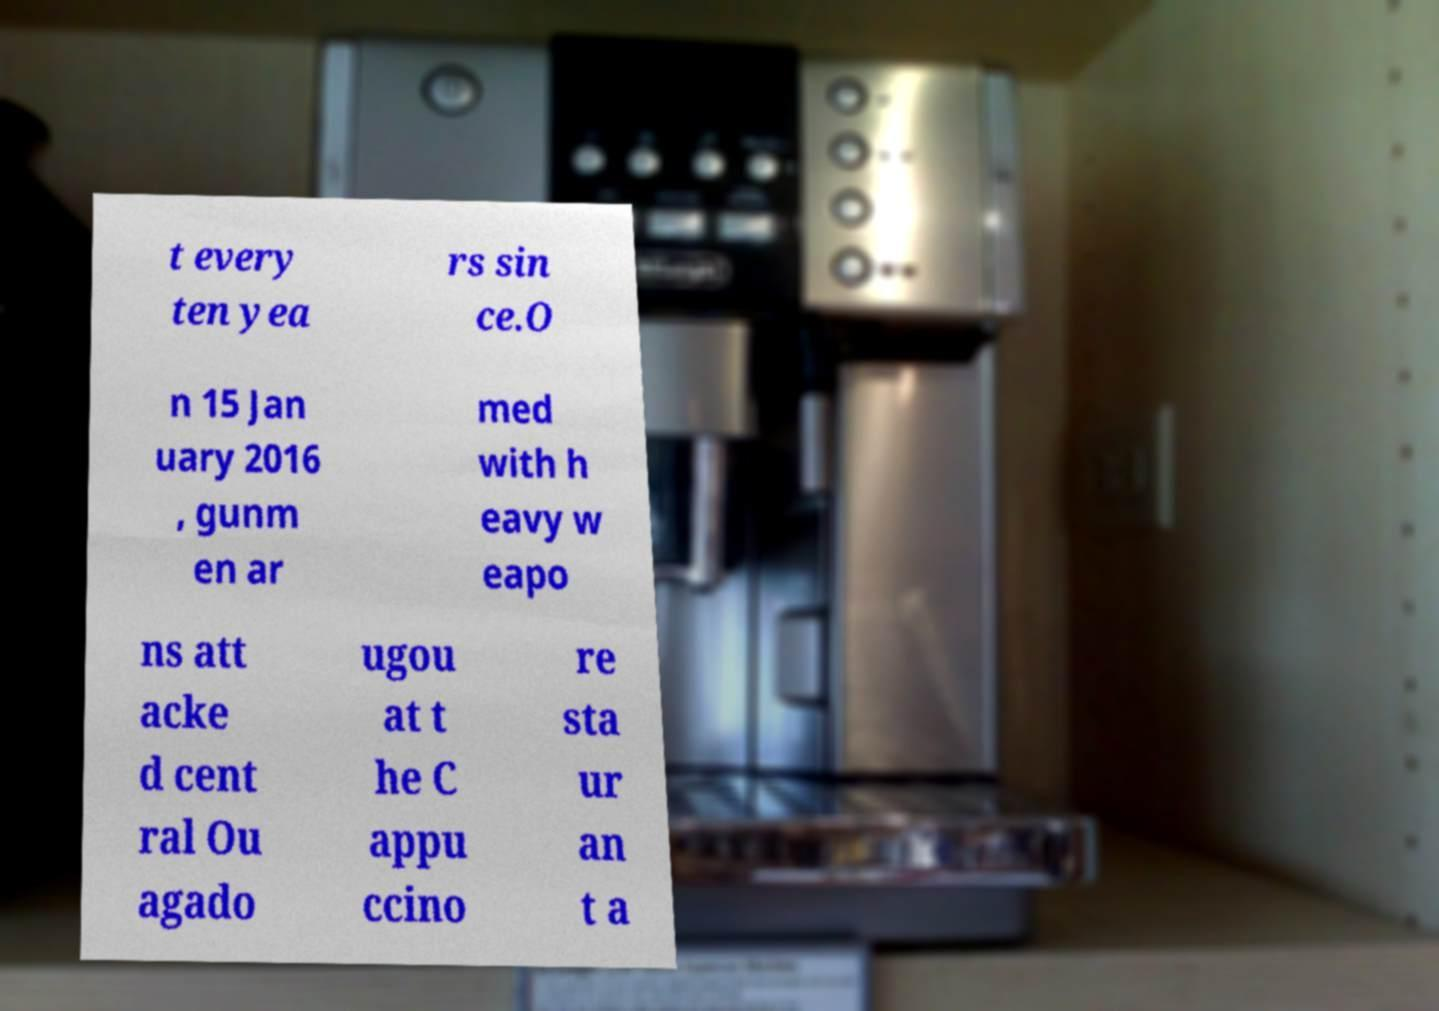Could you assist in decoding the text presented in this image and type it out clearly? t every ten yea rs sin ce.O n 15 Jan uary 2016 , gunm en ar med with h eavy w eapo ns att acke d cent ral Ou agado ugou at t he C appu ccino re sta ur an t a 